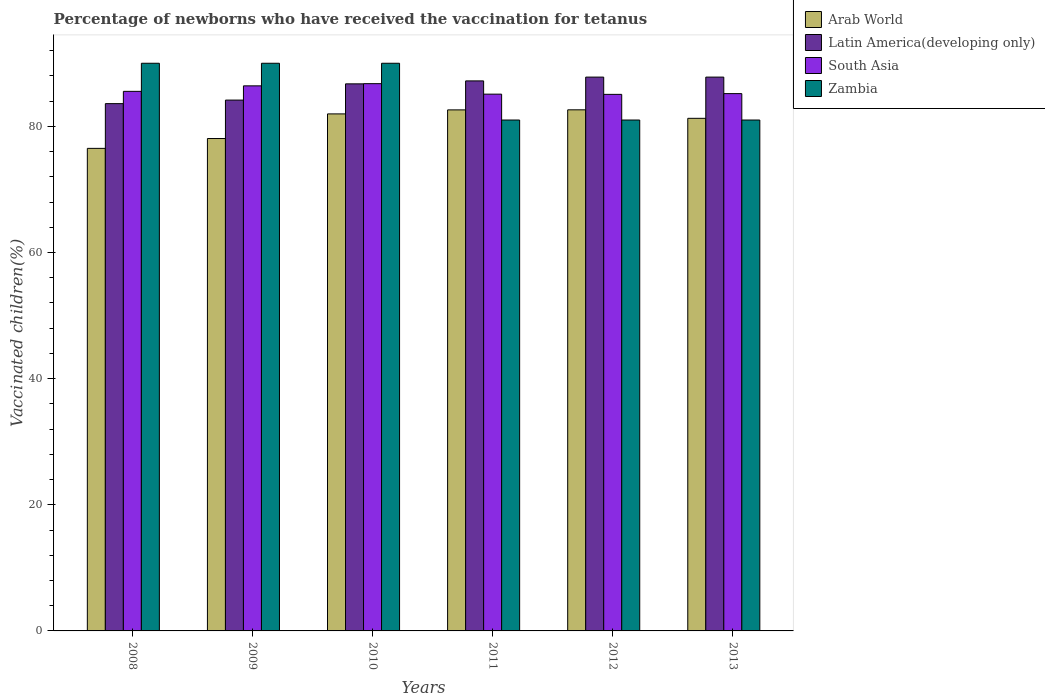How many different coloured bars are there?
Offer a very short reply. 4. How many groups of bars are there?
Offer a very short reply. 6. How many bars are there on the 1st tick from the right?
Provide a short and direct response. 4. In how many cases, is the number of bars for a given year not equal to the number of legend labels?
Your response must be concise. 0. What is the percentage of vaccinated children in Latin America(developing only) in 2008?
Provide a succinct answer. 83.6. Across all years, what is the maximum percentage of vaccinated children in South Asia?
Keep it short and to the point. 86.76. Across all years, what is the minimum percentage of vaccinated children in Latin America(developing only)?
Offer a terse response. 83.6. What is the total percentage of vaccinated children in Zambia in the graph?
Your response must be concise. 513. What is the difference between the percentage of vaccinated children in South Asia in 2011 and that in 2013?
Provide a succinct answer. -0.08. What is the difference between the percentage of vaccinated children in South Asia in 2008 and the percentage of vaccinated children in Zambia in 2009?
Ensure brevity in your answer.  -4.45. What is the average percentage of vaccinated children in South Asia per year?
Your answer should be very brief. 85.68. In the year 2009, what is the difference between the percentage of vaccinated children in South Asia and percentage of vaccinated children in Arab World?
Ensure brevity in your answer.  8.35. What is the ratio of the percentage of vaccinated children in South Asia in 2009 to that in 2010?
Your answer should be compact. 1. Is the difference between the percentage of vaccinated children in South Asia in 2011 and 2012 greater than the difference between the percentage of vaccinated children in Arab World in 2011 and 2012?
Offer a very short reply. Yes. What is the difference between the highest and the second highest percentage of vaccinated children in Arab World?
Provide a short and direct response. 0.01. What is the difference between the highest and the lowest percentage of vaccinated children in Latin America(developing only)?
Make the answer very short. 4.21. In how many years, is the percentage of vaccinated children in South Asia greater than the average percentage of vaccinated children in South Asia taken over all years?
Your answer should be very brief. 2. Is the sum of the percentage of vaccinated children in Arab World in 2009 and 2012 greater than the maximum percentage of vaccinated children in Latin America(developing only) across all years?
Offer a very short reply. Yes. Is it the case that in every year, the sum of the percentage of vaccinated children in Zambia and percentage of vaccinated children in Arab World is greater than the sum of percentage of vaccinated children in South Asia and percentage of vaccinated children in Latin America(developing only)?
Make the answer very short. No. What does the 4th bar from the left in 2012 represents?
Provide a succinct answer. Zambia. Is it the case that in every year, the sum of the percentage of vaccinated children in Latin America(developing only) and percentage of vaccinated children in Arab World is greater than the percentage of vaccinated children in South Asia?
Your answer should be compact. Yes. Are all the bars in the graph horizontal?
Offer a terse response. No. Where does the legend appear in the graph?
Provide a succinct answer. Top right. How many legend labels are there?
Offer a terse response. 4. What is the title of the graph?
Provide a succinct answer. Percentage of newborns who have received the vaccination for tetanus. Does "Armenia" appear as one of the legend labels in the graph?
Give a very brief answer. No. What is the label or title of the Y-axis?
Provide a succinct answer. Vaccinated children(%). What is the Vaccinated children(%) in Arab World in 2008?
Keep it short and to the point. 76.51. What is the Vaccinated children(%) in Latin America(developing only) in 2008?
Offer a very short reply. 83.6. What is the Vaccinated children(%) of South Asia in 2008?
Offer a very short reply. 85.55. What is the Vaccinated children(%) in Zambia in 2008?
Provide a succinct answer. 90. What is the Vaccinated children(%) in Arab World in 2009?
Offer a very short reply. 78.07. What is the Vaccinated children(%) of Latin America(developing only) in 2009?
Keep it short and to the point. 84.16. What is the Vaccinated children(%) of South Asia in 2009?
Keep it short and to the point. 86.42. What is the Vaccinated children(%) in Zambia in 2009?
Your response must be concise. 90. What is the Vaccinated children(%) of Arab World in 2010?
Offer a very short reply. 81.97. What is the Vaccinated children(%) in Latin America(developing only) in 2010?
Keep it short and to the point. 86.73. What is the Vaccinated children(%) of South Asia in 2010?
Keep it short and to the point. 86.76. What is the Vaccinated children(%) in Zambia in 2010?
Provide a succinct answer. 90. What is the Vaccinated children(%) in Arab World in 2011?
Your answer should be very brief. 82.61. What is the Vaccinated children(%) of Latin America(developing only) in 2011?
Provide a short and direct response. 87.2. What is the Vaccinated children(%) in South Asia in 2011?
Your answer should be compact. 85.1. What is the Vaccinated children(%) of Zambia in 2011?
Provide a succinct answer. 81. What is the Vaccinated children(%) of Arab World in 2012?
Make the answer very short. 82.62. What is the Vaccinated children(%) of Latin America(developing only) in 2012?
Provide a short and direct response. 87.8. What is the Vaccinated children(%) of South Asia in 2012?
Give a very brief answer. 85.07. What is the Vaccinated children(%) in Arab World in 2013?
Offer a terse response. 81.27. What is the Vaccinated children(%) of Latin America(developing only) in 2013?
Provide a short and direct response. 87.81. What is the Vaccinated children(%) in South Asia in 2013?
Provide a succinct answer. 85.19. What is the Vaccinated children(%) of Zambia in 2013?
Provide a succinct answer. 81. Across all years, what is the maximum Vaccinated children(%) of Arab World?
Offer a terse response. 82.62. Across all years, what is the maximum Vaccinated children(%) of Latin America(developing only)?
Offer a terse response. 87.81. Across all years, what is the maximum Vaccinated children(%) of South Asia?
Your answer should be compact. 86.76. Across all years, what is the minimum Vaccinated children(%) in Arab World?
Offer a terse response. 76.51. Across all years, what is the minimum Vaccinated children(%) in Latin America(developing only)?
Provide a short and direct response. 83.6. Across all years, what is the minimum Vaccinated children(%) in South Asia?
Keep it short and to the point. 85.07. What is the total Vaccinated children(%) of Arab World in the graph?
Your answer should be very brief. 483.04. What is the total Vaccinated children(%) of Latin America(developing only) in the graph?
Your response must be concise. 517.31. What is the total Vaccinated children(%) in South Asia in the graph?
Offer a very short reply. 514.08. What is the total Vaccinated children(%) in Zambia in the graph?
Provide a succinct answer. 513. What is the difference between the Vaccinated children(%) of Arab World in 2008 and that in 2009?
Your response must be concise. -1.56. What is the difference between the Vaccinated children(%) of Latin America(developing only) in 2008 and that in 2009?
Your answer should be very brief. -0.56. What is the difference between the Vaccinated children(%) of South Asia in 2008 and that in 2009?
Make the answer very short. -0.87. What is the difference between the Vaccinated children(%) in Zambia in 2008 and that in 2009?
Provide a succinct answer. 0. What is the difference between the Vaccinated children(%) of Arab World in 2008 and that in 2010?
Provide a short and direct response. -5.46. What is the difference between the Vaccinated children(%) of Latin America(developing only) in 2008 and that in 2010?
Make the answer very short. -3.14. What is the difference between the Vaccinated children(%) of South Asia in 2008 and that in 2010?
Make the answer very short. -1.22. What is the difference between the Vaccinated children(%) of Arab World in 2008 and that in 2011?
Your response must be concise. -6.1. What is the difference between the Vaccinated children(%) in Latin America(developing only) in 2008 and that in 2011?
Give a very brief answer. -3.61. What is the difference between the Vaccinated children(%) of South Asia in 2008 and that in 2011?
Your answer should be compact. 0.44. What is the difference between the Vaccinated children(%) of Zambia in 2008 and that in 2011?
Make the answer very short. 9. What is the difference between the Vaccinated children(%) of Arab World in 2008 and that in 2012?
Your answer should be compact. -6.11. What is the difference between the Vaccinated children(%) of Latin America(developing only) in 2008 and that in 2012?
Offer a terse response. -4.21. What is the difference between the Vaccinated children(%) in South Asia in 2008 and that in 2012?
Make the answer very short. 0.48. What is the difference between the Vaccinated children(%) in Zambia in 2008 and that in 2012?
Keep it short and to the point. 9. What is the difference between the Vaccinated children(%) in Arab World in 2008 and that in 2013?
Provide a succinct answer. -4.76. What is the difference between the Vaccinated children(%) of Latin America(developing only) in 2008 and that in 2013?
Keep it short and to the point. -4.21. What is the difference between the Vaccinated children(%) of South Asia in 2008 and that in 2013?
Offer a very short reply. 0.36. What is the difference between the Vaccinated children(%) in Arab World in 2009 and that in 2010?
Your response must be concise. -3.9. What is the difference between the Vaccinated children(%) in Latin America(developing only) in 2009 and that in 2010?
Keep it short and to the point. -2.57. What is the difference between the Vaccinated children(%) in South Asia in 2009 and that in 2010?
Offer a very short reply. -0.35. What is the difference between the Vaccinated children(%) of Zambia in 2009 and that in 2010?
Provide a succinct answer. 0. What is the difference between the Vaccinated children(%) of Arab World in 2009 and that in 2011?
Your answer should be compact. -4.54. What is the difference between the Vaccinated children(%) in Latin America(developing only) in 2009 and that in 2011?
Provide a succinct answer. -3.04. What is the difference between the Vaccinated children(%) in South Asia in 2009 and that in 2011?
Your answer should be very brief. 1.32. What is the difference between the Vaccinated children(%) in Arab World in 2009 and that in 2012?
Provide a succinct answer. -4.55. What is the difference between the Vaccinated children(%) of Latin America(developing only) in 2009 and that in 2012?
Provide a short and direct response. -3.64. What is the difference between the Vaccinated children(%) of South Asia in 2009 and that in 2012?
Ensure brevity in your answer.  1.35. What is the difference between the Vaccinated children(%) in Zambia in 2009 and that in 2012?
Keep it short and to the point. 9. What is the difference between the Vaccinated children(%) in Arab World in 2009 and that in 2013?
Your answer should be very brief. -3.2. What is the difference between the Vaccinated children(%) of Latin America(developing only) in 2009 and that in 2013?
Offer a terse response. -3.64. What is the difference between the Vaccinated children(%) of South Asia in 2009 and that in 2013?
Ensure brevity in your answer.  1.23. What is the difference between the Vaccinated children(%) in Zambia in 2009 and that in 2013?
Offer a terse response. 9. What is the difference between the Vaccinated children(%) in Arab World in 2010 and that in 2011?
Give a very brief answer. -0.64. What is the difference between the Vaccinated children(%) in Latin America(developing only) in 2010 and that in 2011?
Offer a terse response. -0.47. What is the difference between the Vaccinated children(%) in South Asia in 2010 and that in 2011?
Give a very brief answer. 1.66. What is the difference between the Vaccinated children(%) of Arab World in 2010 and that in 2012?
Make the answer very short. -0.65. What is the difference between the Vaccinated children(%) in Latin America(developing only) in 2010 and that in 2012?
Make the answer very short. -1.07. What is the difference between the Vaccinated children(%) in South Asia in 2010 and that in 2012?
Your answer should be compact. 1.69. What is the difference between the Vaccinated children(%) of Zambia in 2010 and that in 2012?
Keep it short and to the point. 9. What is the difference between the Vaccinated children(%) in Arab World in 2010 and that in 2013?
Make the answer very short. 0.7. What is the difference between the Vaccinated children(%) of Latin America(developing only) in 2010 and that in 2013?
Offer a terse response. -1.07. What is the difference between the Vaccinated children(%) in South Asia in 2010 and that in 2013?
Your answer should be very brief. 1.58. What is the difference between the Vaccinated children(%) of Zambia in 2010 and that in 2013?
Your response must be concise. 9. What is the difference between the Vaccinated children(%) of Arab World in 2011 and that in 2012?
Ensure brevity in your answer.  -0.01. What is the difference between the Vaccinated children(%) of Latin America(developing only) in 2011 and that in 2012?
Keep it short and to the point. -0.6. What is the difference between the Vaccinated children(%) in Arab World in 2011 and that in 2013?
Your answer should be very brief. 1.34. What is the difference between the Vaccinated children(%) in Latin America(developing only) in 2011 and that in 2013?
Provide a succinct answer. -0.6. What is the difference between the Vaccinated children(%) of South Asia in 2011 and that in 2013?
Provide a succinct answer. -0.08. What is the difference between the Vaccinated children(%) of Arab World in 2012 and that in 2013?
Offer a very short reply. 1.35. What is the difference between the Vaccinated children(%) in Latin America(developing only) in 2012 and that in 2013?
Make the answer very short. -0. What is the difference between the Vaccinated children(%) of South Asia in 2012 and that in 2013?
Make the answer very short. -0.12. What is the difference between the Vaccinated children(%) in Zambia in 2012 and that in 2013?
Your response must be concise. 0. What is the difference between the Vaccinated children(%) in Arab World in 2008 and the Vaccinated children(%) in Latin America(developing only) in 2009?
Give a very brief answer. -7.66. What is the difference between the Vaccinated children(%) of Arab World in 2008 and the Vaccinated children(%) of South Asia in 2009?
Keep it short and to the point. -9.91. What is the difference between the Vaccinated children(%) in Arab World in 2008 and the Vaccinated children(%) in Zambia in 2009?
Keep it short and to the point. -13.49. What is the difference between the Vaccinated children(%) in Latin America(developing only) in 2008 and the Vaccinated children(%) in South Asia in 2009?
Offer a very short reply. -2.82. What is the difference between the Vaccinated children(%) of Latin America(developing only) in 2008 and the Vaccinated children(%) of Zambia in 2009?
Keep it short and to the point. -6.4. What is the difference between the Vaccinated children(%) of South Asia in 2008 and the Vaccinated children(%) of Zambia in 2009?
Offer a terse response. -4.45. What is the difference between the Vaccinated children(%) in Arab World in 2008 and the Vaccinated children(%) in Latin America(developing only) in 2010?
Make the answer very short. -10.23. What is the difference between the Vaccinated children(%) of Arab World in 2008 and the Vaccinated children(%) of South Asia in 2010?
Your answer should be very brief. -10.26. What is the difference between the Vaccinated children(%) of Arab World in 2008 and the Vaccinated children(%) of Zambia in 2010?
Offer a terse response. -13.49. What is the difference between the Vaccinated children(%) of Latin America(developing only) in 2008 and the Vaccinated children(%) of South Asia in 2010?
Give a very brief answer. -3.17. What is the difference between the Vaccinated children(%) of Latin America(developing only) in 2008 and the Vaccinated children(%) of Zambia in 2010?
Provide a short and direct response. -6.4. What is the difference between the Vaccinated children(%) of South Asia in 2008 and the Vaccinated children(%) of Zambia in 2010?
Your response must be concise. -4.45. What is the difference between the Vaccinated children(%) of Arab World in 2008 and the Vaccinated children(%) of Latin America(developing only) in 2011?
Keep it short and to the point. -10.7. What is the difference between the Vaccinated children(%) in Arab World in 2008 and the Vaccinated children(%) in South Asia in 2011?
Offer a very short reply. -8.6. What is the difference between the Vaccinated children(%) in Arab World in 2008 and the Vaccinated children(%) in Zambia in 2011?
Offer a terse response. -4.49. What is the difference between the Vaccinated children(%) in Latin America(developing only) in 2008 and the Vaccinated children(%) in South Asia in 2011?
Ensure brevity in your answer.  -1.5. What is the difference between the Vaccinated children(%) of Latin America(developing only) in 2008 and the Vaccinated children(%) of Zambia in 2011?
Keep it short and to the point. 2.6. What is the difference between the Vaccinated children(%) of South Asia in 2008 and the Vaccinated children(%) of Zambia in 2011?
Your response must be concise. 4.55. What is the difference between the Vaccinated children(%) in Arab World in 2008 and the Vaccinated children(%) in Latin America(developing only) in 2012?
Your response must be concise. -11.3. What is the difference between the Vaccinated children(%) of Arab World in 2008 and the Vaccinated children(%) of South Asia in 2012?
Your response must be concise. -8.56. What is the difference between the Vaccinated children(%) of Arab World in 2008 and the Vaccinated children(%) of Zambia in 2012?
Your answer should be compact. -4.49. What is the difference between the Vaccinated children(%) in Latin America(developing only) in 2008 and the Vaccinated children(%) in South Asia in 2012?
Offer a very short reply. -1.47. What is the difference between the Vaccinated children(%) of Latin America(developing only) in 2008 and the Vaccinated children(%) of Zambia in 2012?
Your response must be concise. 2.6. What is the difference between the Vaccinated children(%) in South Asia in 2008 and the Vaccinated children(%) in Zambia in 2012?
Your response must be concise. 4.55. What is the difference between the Vaccinated children(%) in Arab World in 2008 and the Vaccinated children(%) in Latin America(developing only) in 2013?
Ensure brevity in your answer.  -11.3. What is the difference between the Vaccinated children(%) in Arab World in 2008 and the Vaccinated children(%) in South Asia in 2013?
Ensure brevity in your answer.  -8.68. What is the difference between the Vaccinated children(%) of Arab World in 2008 and the Vaccinated children(%) of Zambia in 2013?
Keep it short and to the point. -4.49. What is the difference between the Vaccinated children(%) of Latin America(developing only) in 2008 and the Vaccinated children(%) of South Asia in 2013?
Your answer should be very brief. -1.59. What is the difference between the Vaccinated children(%) in Latin America(developing only) in 2008 and the Vaccinated children(%) in Zambia in 2013?
Keep it short and to the point. 2.6. What is the difference between the Vaccinated children(%) of South Asia in 2008 and the Vaccinated children(%) of Zambia in 2013?
Give a very brief answer. 4.55. What is the difference between the Vaccinated children(%) of Arab World in 2009 and the Vaccinated children(%) of Latin America(developing only) in 2010?
Keep it short and to the point. -8.67. What is the difference between the Vaccinated children(%) of Arab World in 2009 and the Vaccinated children(%) of South Asia in 2010?
Ensure brevity in your answer.  -8.7. What is the difference between the Vaccinated children(%) of Arab World in 2009 and the Vaccinated children(%) of Zambia in 2010?
Offer a terse response. -11.93. What is the difference between the Vaccinated children(%) of Latin America(developing only) in 2009 and the Vaccinated children(%) of South Asia in 2010?
Make the answer very short. -2.6. What is the difference between the Vaccinated children(%) of Latin America(developing only) in 2009 and the Vaccinated children(%) of Zambia in 2010?
Your response must be concise. -5.84. What is the difference between the Vaccinated children(%) in South Asia in 2009 and the Vaccinated children(%) in Zambia in 2010?
Provide a succinct answer. -3.58. What is the difference between the Vaccinated children(%) of Arab World in 2009 and the Vaccinated children(%) of Latin America(developing only) in 2011?
Provide a succinct answer. -9.14. What is the difference between the Vaccinated children(%) of Arab World in 2009 and the Vaccinated children(%) of South Asia in 2011?
Make the answer very short. -7.03. What is the difference between the Vaccinated children(%) in Arab World in 2009 and the Vaccinated children(%) in Zambia in 2011?
Ensure brevity in your answer.  -2.93. What is the difference between the Vaccinated children(%) in Latin America(developing only) in 2009 and the Vaccinated children(%) in South Asia in 2011?
Provide a short and direct response. -0.94. What is the difference between the Vaccinated children(%) in Latin America(developing only) in 2009 and the Vaccinated children(%) in Zambia in 2011?
Provide a short and direct response. 3.16. What is the difference between the Vaccinated children(%) of South Asia in 2009 and the Vaccinated children(%) of Zambia in 2011?
Offer a terse response. 5.42. What is the difference between the Vaccinated children(%) of Arab World in 2009 and the Vaccinated children(%) of Latin America(developing only) in 2012?
Keep it short and to the point. -9.74. What is the difference between the Vaccinated children(%) of Arab World in 2009 and the Vaccinated children(%) of South Asia in 2012?
Offer a terse response. -7. What is the difference between the Vaccinated children(%) in Arab World in 2009 and the Vaccinated children(%) in Zambia in 2012?
Your answer should be very brief. -2.93. What is the difference between the Vaccinated children(%) in Latin America(developing only) in 2009 and the Vaccinated children(%) in South Asia in 2012?
Ensure brevity in your answer.  -0.91. What is the difference between the Vaccinated children(%) of Latin America(developing only) in 2009 and the Vaccinated children(%) of Zambia in 2012?
Your answer should be very brief. 3.16. What is the difference between the Vaccinated children(%) of South Asia in 2009 and the Vaccinated children(%) of Zambia in 2012?
Make the answer very short. 5.42. What is the difference between the Vaccinated children(%) in Arab World in 2009 and the Vaccinated children(%) in Latin America(developing only) in 2013?
Your answer should be very brief. -9.74. What is the difference between the Vaccinated children(%) in Arab World in 2009 and the Vaccinated children(%) in South Asia in 2013?
Offer a very short reply. -7.12. What is the difference between the Vaccinated children(%) of Arab World in 2009 and the Vaccinated children(%) of Zambia in 2013?
Ensure brevity in your answer.  -2.93. What is the difference between the Vaccinated children(%) of Latin America(developing only) in 2009 and the Vaccinated children(%) of South Asia in 2013?
Offer a very short reply. -1.02. What is the difference between the Vaccinated children(%) of Latin America(developing only) in 2009 and the Vaccinated children(%) of Zambia in 2013?
Offer a very short reply. 3.16. What is the difference between the Vaccinated children(%) of South Asia in 2009 and the Vaccinated children(%) of Zambia in 2013?
Offer a very short reply. 5.42. What is the difference between the Vaccinated children(%) in Arab World in 2010 and the Vaccinated children(%) in Latin America(developing only) in 2011?
Your response must be concise. -5.23. What is the difference between the Vaccinated children(%) in Arab World in 2010 and the Vaccinated children(%) in South Asia in 2011?
Make the answer very short. -3.13. What is the difference between the Vaccinated children(%) of Arab World in 2010 and the Vaccinated children(%) of Zambia in 2011?
Your response must be concise. 0.97. What is the difference between the Vaccinated children(%) of Latin America(developing only) in 2010 and the Vaccinated children(%) of South Asia in 2011?
Your answer should be compact. 1.63. What is the difference between the Vaccinated children(%) in Latin America(developing only) in 2010 and the Vaccinated children(%) in Zambia in 2011?
Make the answer very short. 5.73. What is the difference between the Vaccinated children(%) of South Asia in 2010 and the Vaccinated children(%) of Zambia in 2011?
Provide a succinct answer. 5.76. What is the difference between the Vaccinated children(%) of Arab World in 2010 and the Vaccinated children(%) of Latin America(developing only) in 2012?
Your answer should be compact. -5.83. What is the difference between the Vaccinated children(%) of Arab World in 2010 and the Vaccinated children(%) of South Asia in 2012?
Offer a very short reply. -3.1. What is the difference between the Vaccinated children(%) of Arab World in 2010 and the Vaccinated children(%) of Zambia in 2012?
Offer a terse response. 0.97. What is the difference between the Vaccinated children(%) in Latin America(developing only) in 2010 and the Vaccinated children(%) in South Asia in 2012?
Keep it short and to the point. 1.67. What is the difference between the Vaccinated children(%) of Latin America(developing only) in 2010 and the Vaccinated children(%) of Zambia in 2012?
Give a very brief answer. 5.73. What is the difference between the Vaccinated children(%) of South Asia in 2010 and the Vaccinated children(%) of Zambia in 2012?
Offer a terse response. 5.76. What is the difference between the Vaccinated children(%) of Arab World in 2010 and the Vaccinated children(%) of Latin America(developing only) in 2013?
Your response must be concise. -5.84. What is the difference between the Vaccinated children(%) in Arab World in 2010 and the Vaccinated children(%) in South Asia in 2013?
Your answer should be compact. -3.22. What is the difference between the Vaccinated children(%) of Arab World in 2010 and the Vaccinated children(%) of Zambia in 2013?
Ensure brevity in your answer.  0.97. What is the difference between the Vaccinated children(%) of Latin America(developing only) in 2010 and the Vaccinated children(%) of South Asia in 2013?
Your answer should be very brief. 1.55. What is the difference between the Vaccinated children(%) of Latin America(developing only) in 2010 and the Vaccinated children(%) of Zambia in 2013?
Your answer should be very brief. 5.73. What is the difference between the Vaccinated children(%) in South Asia in 2010 and the Vaccinated children(%) in Zambia in 2013?
Your answer should be compact. 5.76. What is the difference between the Vaccinated children(%) of Arab World in 2011 and the Vaccinated children(%) of Latin America(developing only) in 2012?
Offer a terse response. -5.2. What is the difference between the Vaccinated children(%) of Arab World in 2011 and the Vaccinated children(%) of South Asia in 2012?
Give a very brief answer. -2.46. What is the difference between the Vaccinated children(%) of Arab World in 2011 and the Vaccinated children(%) of Zambia in 2012?
Give a very brief answer. 1.61. What is the difference between the Vaccinated children(%) of Latin America(developing only) in 2011 and the Vaccinated children(%) of South Asia in 2012?
Your answer should be compact. 2.14. What is the difference between the Vaccinated children(%) in Latin America(developing only) in 2011 and the Vaccinated children(%) in Zambia in 2012?
Ensure brevity in your answer.  6.2. What is the difference between the Vaccinated children(%) in South Asia in 2011 and the Vaccinated children(%) in Zambia in 2012?
Offer a terse response. 4.1. What is the difference between the Vaccinated children(%) of Arab World in 2011 and the Vaccinated children(%) of Latin America(developing only) in 2013?
Your answer should be very brief. -5.2. What is the difference between the Vaccinated children(%) of Arab World in 2011 and the Vaccinated children(%) of South Asia in 2013?
Give a very brief answer. -2.58. What is the difference between the Vaccinated children(%) in Arab World in 2011 and the Vaccinated children(%) in Zambia in 2013?
Your answer should be very brief. 1.61. What is the difference between the Vaccinated children(%) in Latin America(developing only) in 2011 and the Vaccinated children(%) in South Asia in 2013?
Offer a very short reply. 2.02. What is the difference between the Vaccinated children(%) of Latin America(developing only) in 2011 and the Vaccinated children(%) of Zambia in 2013?
Make the answer very short. 6.2. What is the difference between the Vaccinated children(%) of South Asia in 2011 and the Vaccinated children(%) of Zambia in 2013?
Give a very brief answer. 4.1. What is the difference between the Vaccinated children(%) of Arab World in 2012 and the Vaccinated children(%) of Latin America(developing only) in 2013?
Offer a very short reply. -5.19. What is the difference between the Vaccinated children(%) in Arab World in 2012 and the Vaccinated children(%) in South Asia in 2013?
Your response must be concise. -2.57. What is the difference between the Vaccinated children(%) in Arab World in 2012 and the Vaccinated children(%) in Zambia in 2013?
Keep it short and to the point. 1.62. What is the difference between the Vaccinated children(%) in Latin America(developing only) in 2012 and the Vaccinated children(%) in South Asia in 2013?
Your response must be concise. 2.62. What is the difference between the Vaccinated children(%) of Latin America(developing only) in 2012 and the Vaccinated children(%) of Zambia in 2013?
Give a very brief answer. 6.8. What is the difference between the Vaccinated children(%) of South Asia in 2012 and the Vaccinated children(%) of Zambia in 2013?
Give a very brief answer. 4.07. What is the average Vaccinated children(%) of Arab World per year?
Provide a succinct answer. 80.51. What is the average Vaccinated children(%) in Latin America(developing only) per year?
Make the answer very short. 86.22. What is the average Vaccinated children(%) in South Asia per year?
Keep it short and to the point. 85.68. What is the average Vaccinated children(%) of Zambia per year?
Offer a very short reply. 85.5. In the year 2008, what is the difference between the Vaccinated children(%) in Arab World and Vaccinated children(%) in Latin America(developing only)?
Provide a short and direct response. -7.09. In the year 2008, what is the difference between the Vaccinated children(%) of Arab World and Vaccinated children(%) of South Asia?
Provide a succinct answer. -9.04. In the year 2008, what is the difference between the Vaccinated children(%) in Arab World and Vaccinated children(%) in Zambia?
Make the answer very short. -13.49. In the year 2008, what is the difference between the Vaccinated children(%) in Latin America(developing only) and Vaccinated children(%) in South Asia?
Your answer should be very brief. -1.95. In the year 2008, what is the difference between the Vaccinated children(%) of Latin America(developing only) and Vaccinated children(%) of Zambia?
Your response must be concise. -6.4. In the year 2008, what is the difference between the Vaccinated children(%) of South Asia and Vaccinated children(%) of Zambia?
Your response must be concise. -4.45. In the year 2009, what is the difference between the Vaccinated children(%) in Arab World and Vaccinated children(%) in Latin America(developing only)?
Your response must be concise. -6.1. In the year 2009, what is the difference between the Vaccinated children(%) of Arab World and Vaccinated children(%) of South Asia?
Your answer should be very brief. -8.35. In the year 2009, what is the difference between the Vaccinated children(%) of Arab World and Vaccinated children(%) of Zambia?
Provide a short and direct response. -11.93. In the year 2009, what is the difference between the Vaccinated children(%) in Latin America(developing only) and Vaccinated children(%) in South Asia?
Make the answer very short. -2.25. In the year 2009, what is the difference between the Vaccinated children(%) in Latin America(developing only) and Vaccinated children(%) in Zambia?
Provide a short and direct response. -5.84. In the year 2009, what is the difference between the Vaccinated children(%) of South Asia and Vaccinated children(%) of Zambia?
Provide a short and direct response. -3.58. In the year 2010, what is the difference between the Vaccinated children(%) of Arab World and Vaccinated children(%) of Latin America(developing only)?
Provide a short and direct response. -4.76. In the year 2010, what is the difference between the Vaccinated children(%) of Arab World and Vaccinated children(%) of South Asia?
Offer a very short reply. -4.79. In the year 2010, what is the difference between the Vaccinated children(%) of Arab World and Vaccinated children(%) of Zambia?
Your response must be concise. -8.03. In the year 2010, what is the difference between the Vaccinated children(%) in Latin America(developing only) and Vaccinated children(%) in South Asia?
Give a very brief answer. -0.03. In the year 2010, what is the difference between the Vaccinated children(%) of Latin America(developing only) and Vaccinated children(%) of Zambia?
Your answer should be compact. -3.27. In the year 2010, what is the difference between the Vaccinated children(%) in South Asia and Vaccinated children(%) in Zambia?
Keep it short and to the point. -3.24. In the year 2011, what is the difference between the Vaccinated children(%) in Arab World and Vaccinated children(%) in Latin America(developing only)?
Ensure brevity in your answer.  -4.6. In the year 2011, what is the difference between the Vaccinated children(%) of Arab World and Vaccinated children(%) of South Asia?
Provide a succinct answer. -2.5. In the year 2011, what is the difference between the Vaccinated children(%) in Arab World and Vaccinated children(%) in Zambia?
Your answer should be very brief. 1.61. In the year 2011, what is the difference between the Vaccinated children(%) in Latin America(developing only) and Vaccinated children(%) in South Asia?
Ensure brevity in your answer.  2.1. In the year 2011, what is the difference between the Vaccinated children(%) in Latin America(developing only) and Vaccinated children(%) in Zambia?
Provide a succinct answer. 6.2. In the year 2011, what is the difference between the Vaccinated children(%) in South Asia and Vaccinated children(%) in Zambia?
Offer a very short reply. 4.1. In the year 2012, what is the difference between the Vaccinated children(%) of Arab World and Vaccinated children(%) of Latin America(developing only)?
Make the answer very short. -5.19. In the year 2012, what is the difference between the Vaccinated children(%) of Arab World and Vaccinated children(%) of South Asia?
Provide a succinct answer. -2.45. In the year 2012, what is the difference between the Vaccinated children(%) of Arab World and Vaccinated children(%) of Zambia?
Provide a succinct answer. 1.62. In the year 2012, what is the difference between the Vaccinated children(%) in Latin America(developing only) and Vaccinated children(%) in South Asia?
Your response must be concise. 2.74. In the year 2012, what is the difference between the Vaccinated children(%) of Latin America(developing only) and Vaccinated children(%) of Zambia?
Keep it short and to the point. 6.8. In the year 2012, what is the difference between the Vaccinated children(%) in South Asia and Vaccinated children(%) in Zambia?
Offer a very short reply. 4.07. In the year 2013, what is the difference between the Vaccinated children(%) of Arab World and Vaccinated children(%) of Latin America(developing only)?
Your answer should be compact. -6.54. In the year 2013, what is the difference between the Vaccinated children(%) in Arab World and Vaccinated children(%) in South Asia?
Offer a terse response. -3.92. In the year 2013, what is the difference between the Vaccinated children(%) of Arab World and Vaccinated children(%) of Zambia?
Ensure brevity in your answer.  0.27. In the year 2013, what is the difference between the Vaccinated children(%) in Latin America(developing only) and Vaccinated children(%) in South Asia?
Give a very brief answer. 2.62. In the year 2013, what is the difference between the Vaccinated children(%) in Latin America(developing only) and Vaccinated children(%) in Zambia?
Make the answer very short. 6.81. In the year 2013, what is the difference between the Vaccinated children(%) of South Asia and Vaccinated children(%) of Zambia?
Your response must be concise. 4.19. What is the ratio of the Vaccinated children(%) of Latin America(developing only) in 2008 to that in 2009?
Provide a succinct answer. 0.99. What is the ratio of the Vaccinated children(%) of Zambia in 2008 to that in 2009?
Your answer should be compact. 1. What is the ratio of the Vaccinated children(%) in Latin America(developing only) in 2008 to that in 2010?
Your answer should be very brief. 0.96. What is the ratio of the Vaccinated children(%) of Zambia in 2008 to that in 2010?
Give a very brief answer. 1. What is the ratio of the Vaccinated children(%) of Arab World in 2008 to that in 2011?
Make the answer very short. 0.93. What is the ratio of the Vaccinated children(%) in Latin America(developing only) in 2008 to that in 2011?
Give a very brief answer. 0.96. What is the ratio of the Vaccinated children(%) of South Asia in 2008 to that in 2011?
Ensure brevity in your answer.  1.01. What is the ratio of the Vaccinated children(%) of Arab World in 2008 to that in 2012?
Your response must be concise. 0.93. What is the ratio of the Vaccinated children(%) of Latin America(developing only) in 2008 to that in 2012?
Keep it short and to the point. 0.95. What is the ratio of the Vaccinated children(%) of South Asia in 2008 to that in 2012?
Ensure brevity in your answer.  1.01. What is the ratio of the Vaccinated children(%) in Zambia in 2008 to that in 2012?
Your response must be concise. 1.11. What is the ratio of the Vaccinated children(%) in Arab World in 2008 to that in 2013?
Your answer should be compact. 0.94. What is the ratio of the Vaccinated children(%) of Latin America(developing only) in 2008 to that in 2013?
Keep it short and to the point. 0.95. What is the ratio of the Vaccinated children(%) of Zambia in 2008 to that in 2013?
Your answer should be very brief. 1.11. What is the ratio of the Vaccinated children(%) in Latin America(developing only) in 2009 to that in 2010?
Your answer should be very brief. 0.97. What is the ratio of the Vaccinated children(%) of Zambia in 2009 to that in 2010?
Your answer should be compact. 1. What is the ratio of the Vaccinated children(%) of Arab World in 2009 to that in 2011?
Your answer should be very brief. 0.94. What is the ratio of the Vaccinated children(%) of Latin America(developing only) in 2009 to that in 2011?
Offer a terse response. 0.97. What is the ratio of the Vaccinated children(%) in South Asia in 2009 to that in 2011?
Give a very brief answer. 1.02. What is the ratio of the Vaccinated children(%) of Arab World in 2009 to that in 2012?
Make the answer very short. 0.94. What is the ratio of the Vaccinated children(%) in Latin America(developing only) in 2009 to that in 2012?
Provide a short and direct response. 0.96. What is the ratio of the Vaccinated children(%) of South Asia in 2009 to that in 2012?
Give a very brief answer. 1.02. What is the ratio of the Vaccinated children(%) in Arab World in 2009 to that in 2013?
Your answer should be compact. 0.96. What is the ratio of the Vaccinated children(%) in Latin America(developing only) in 2009 to that in 2013?
Your answer should be compact. 0.96. What is the ratio of the Vaccinated children(%) of South Asia in 2009 to that in 2013?
Offer a terse response. 1.01. What is the ratio of the Vaccinated children(%) in Zambia in 2009 to that in 2013?
Give a very brief answer. 1.11. What is the ratio of the Vaccinated children(%) of Latin America(developing only) in 2010 to that in 2011?
Your response must be concise. 0.99. What is the ratio of the Vaccinated children(%) of South Asia in 2010 to that in 2011?
Give a very brief answer. 1.02. What is the ratio of the Vaccinated children(%) of South Asia in 2010 to that in 2012?
Provide a succinct answer. 1.02. What is the ratio of the Vaccinated children(%) in Arab World in 2010 to that in 2013?
Make the answer very short. 1.01. What is the ratio of the Vaccinated children(%) in Latin America(developing only) in 2010 to that in 2013?
Provide a succinct answer. 0.99. What is the ratio of the Vaccinated children(%) of South Asia in 2010 to that in 2013?
Your response must be concise. 1.02. What is the ratio of the Vaccinated children(%) in Arab World in 2011 to that in 2012?
Your answer should be very brief. 1. What is the ratio of the Vaccinated children(%) in Zambia in 2011 to that in 2012?
Provide a succinct answer. 1. What is the ratio of the Vaccinated children(%) of Arab World in 2011 to that in 2013?
Provide a short and direct response. 1.02. What is the ratio of the Vaccinated children(%) of Latin America(developing only) in 2011 to that in 2013?
Your response must be concise. 0.99. What is the ratio of the Vaccinated children(%) in Arab World in 2012 to that in 2013?
Provide a succinct answer. 1.02. What is the ratio of the Vaccinated children(%) in South Asia in 2012 to that in 2013?
Offer a terse response. 1. What is the ratio of the Vaccinated children(%) of Zambia in 2012 to that in 2013?
Keep it short and to the point. 1. What is the difference between the highest and the second highest Vaccinated children(%) in Arab World?
Provide a succinct answer. 0.01. What is the difference between the highest and the second highest Vaccinated children(%) in Latin America(developing only)?
Give a very brief answer. 0. What is the difference between the highest and the second highest Vaccinated children(%) in South Asia?
Your answer should be compact. 0.35. What is the difference between the highest and the lowest Vaccinated children(%) in Arab World?
Give a very brief answer. 6.11. What is the difference between the highest and the lowest Vaccinated children(%) of Latin America(developing only)?
Provide a succinct answer. 4.21. What is the difference between the highest and the lowest Vaccinated children(%) of South Asia?
Provide a short and direct response. 1.69. What is the difference between the highest and the lowest Vaccinated children(%) in Zambia?
Ensure brevity in your answer.  9. 